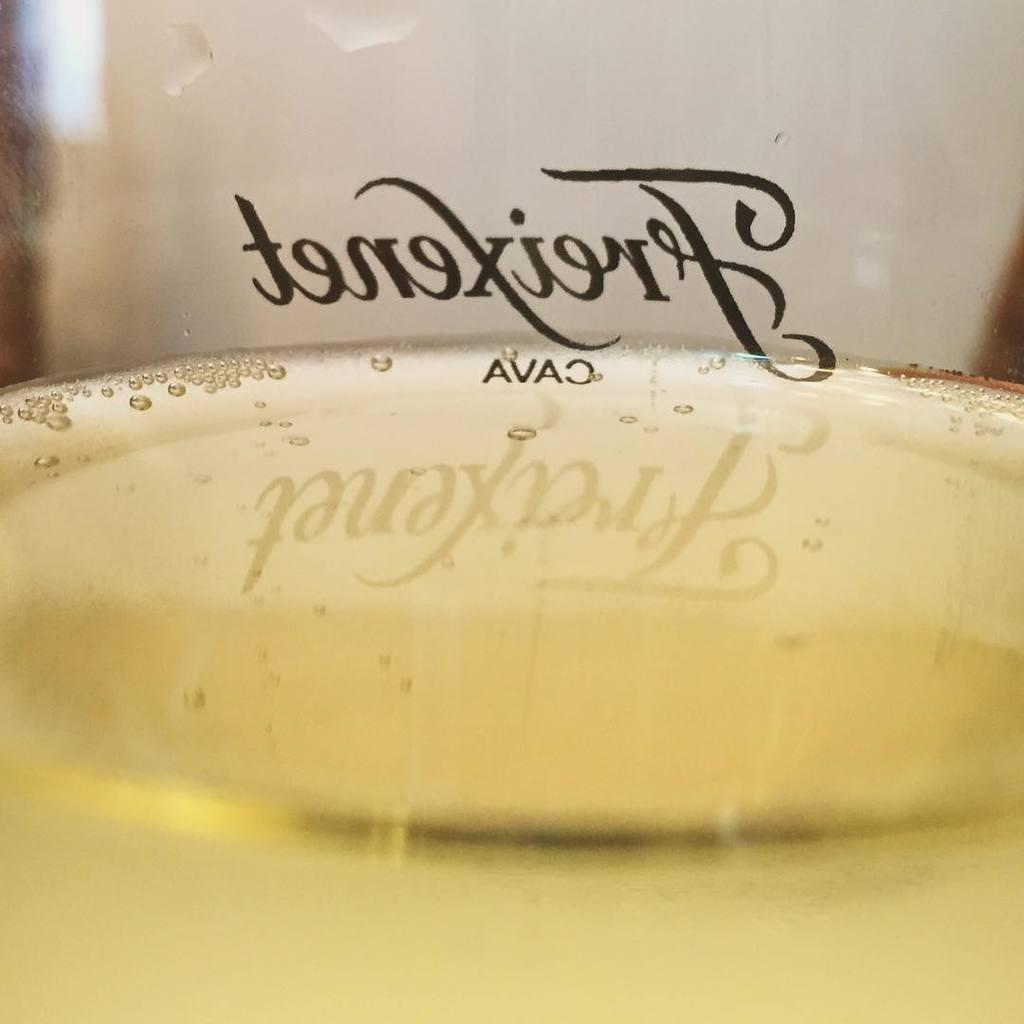What is in the glass that is visible in the center of the image? There is water in a glass in the center of the image. Is there any text or writing on the glass? Yes, there is text on the glass. What can be seen in the background of the image? There are other objects visible in the background of the image. Can you see any feathers floating in the water in the glass? No, there are no feathers visible in the water in the glass. Are there any geese present in the image? There is no mention of geese in the provided facts, so we cannot determine if they are present in the image. 